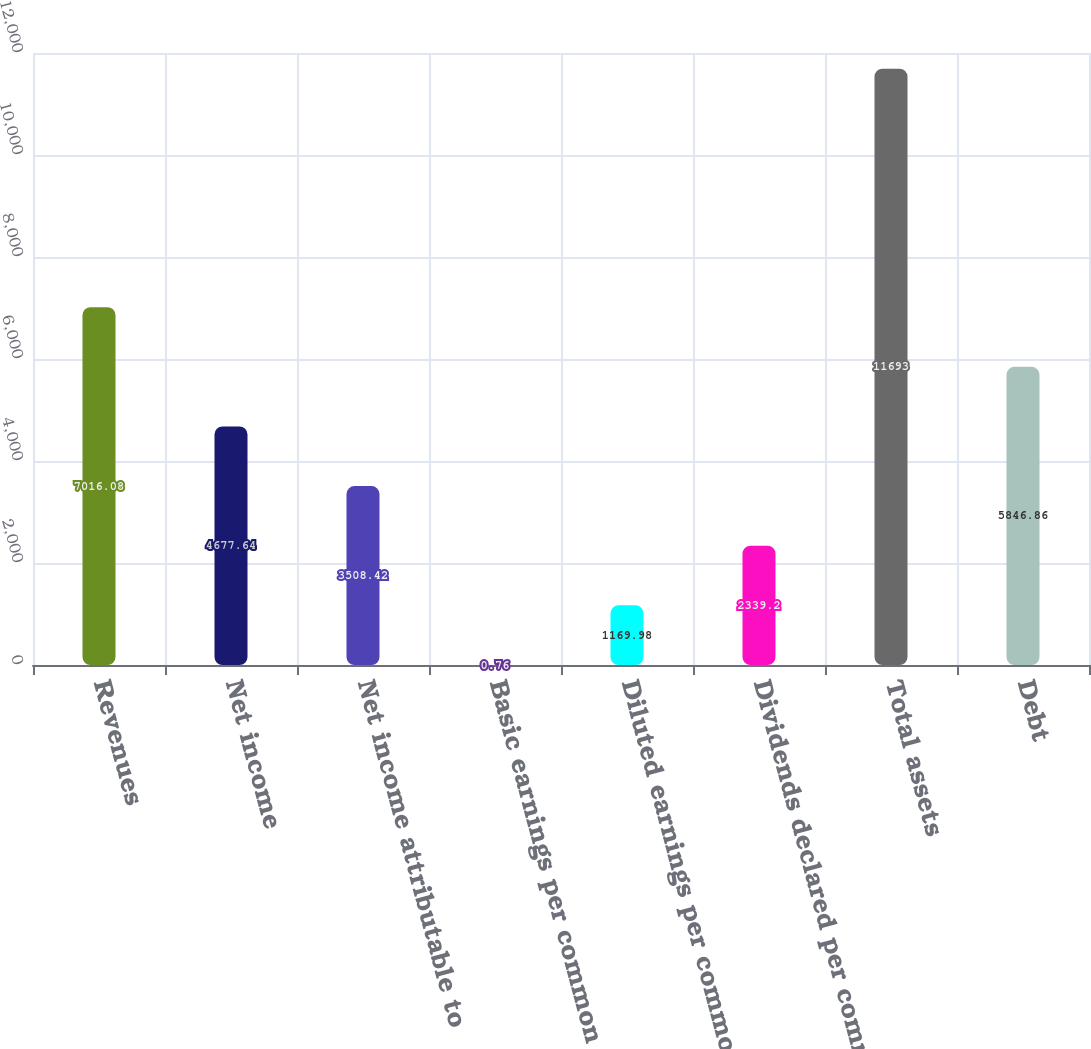<chart> <loc_0><loc_0><loc_500><loc_500><bar_chart><fcel>Revenues<fcel>Net income<fcel>Net income attributable to<fcel>Basic earnings per common<fcel>Diluted earnings per common<fcel>Dividends declared per common<fcel>Total assets<fcel>Debt<nl><fcel>7016.08<fcel>4677.64<fcel>3508.42<fcel>0.76<fcel>1169.98<fcel>2339.2<fcel>11693<fcel>5846.86<nl></chart> 